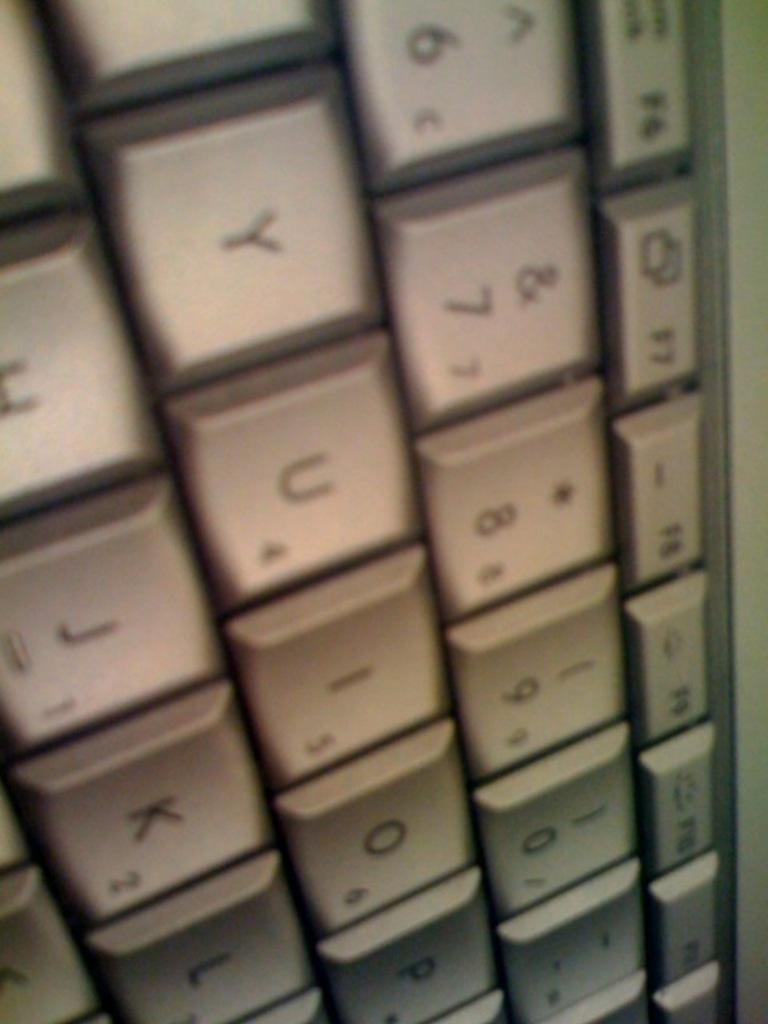What key is to the left of the u?
Offer a terse response. Y. What number is the asterisk?
Provide a short and direct response. 8. 